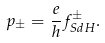Convert formula to latex. <formula><loc_0><loc_0><loc_500><loc_500>p _ { \pm } = \frac { e } { h } f _ { S d H } ^ { \pm } .</formula> 